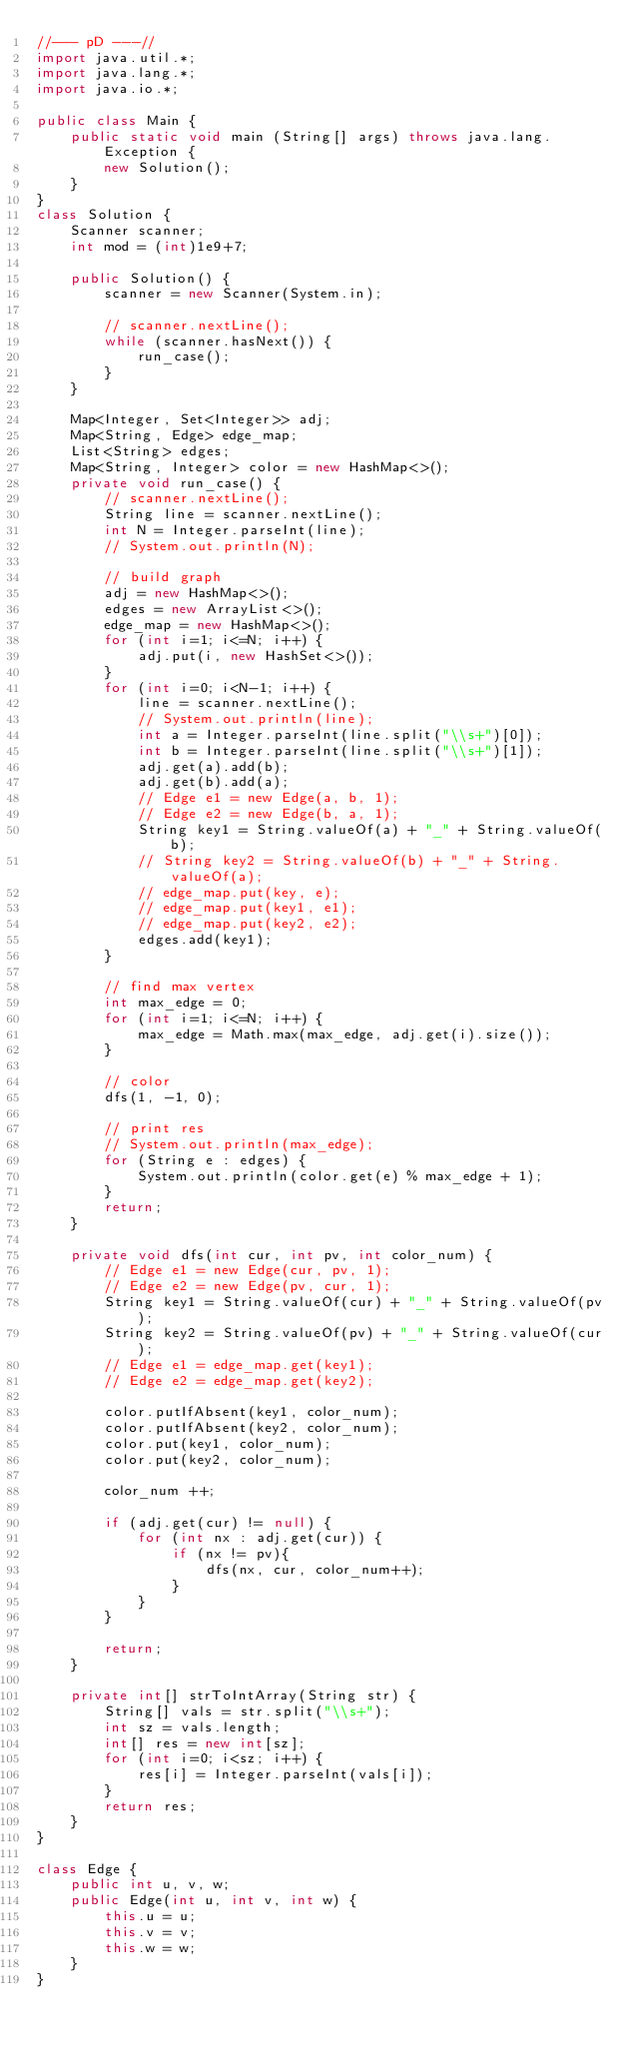<code> <loc_0><loc_0><loc_500><loc_500><_Java_>//--- pD ---//
import java.util.*;
import java.lang.*;
import java.io.*;

public class Main {
	public static void main (String[] args) throws java.lang.Exception {
		new Solution();
	}
}
class Solution {
	Scanner scanner;
	int mod = (int)1e9+7;

	public Solution() {
		scanner = new Scanner(System.in);

		// scanner.nextLine();
		while (scanner.hasNext()) {
			run_case();
		}
	}

	Map<Integer, Set<Integer>> adj;
	Map<String, Edge> edge_map;
	List<String> edges;
	Map<String, Integer> color = new HashMap<>();
	private void run_case() {
		// scanner.nextLine();
		String line = scanner.nextLine();
		int N = Integer.parseInt(line);
		// System.out.println(N);

		// build graph
		adj = new HashMap<>();
		edges = new ArrayList<>();
		edge_map = new HashMap<>();
		for (int i=1; i<=N; i++) {
			adj.put(i, new HashSet<>());
		}
		for (int i=0; i<N-1; i++) {
			line = scanner.nextLine();
			// System.out.println(line);
			int a = Integer.parseInt(line.split("\\s+")[0]);
			int b = Integer.parseInt(line.split("\\s+")[1]);
			adj.get(a).add(b);
			adj.get(b).add(a);
			// Edge e1 = new Edge(a, b, 1);
			// Edge e2 = new Edge(b, a, 1);
			String key1 = String.valueOf(a) + "_" + String.valueOf(b);
			// String key2 = String.valueOf(b) + "_" + String.valueOf(a);
			// edge_map.put(key, e);
			// edge_map.put(key1, e1);
			// edge_map.put(key2, e2);
			edges.add(key1);
		}

		// find max vertex
		int max_edge = 0;
		for (int i=1; i<=N; i++) {
			max_edge = Math.max(max_edge, adj.get(i).size());
		}

		// color
		dfs(1, -1, 0);

		// print res
		// System.out.println(max_edge);
		for (String e : edges) {
			System.out.println(color.get(e) % max_edge + 1);
		}
		return;
	}

	private void dfs(int cur, int pv, int color_num) {
		// Edge e1 = new Edge(cur, pv, 1);
		// Edge e2 = new Edge(pv, cur, 1);
		String key1 = String.valueOf(cur) + "_" + String.valueOf(pv);
		String key2 = String.valueOf(pv) + "_" + String.valueOf(cur);
		// Edge e1 = edge_map.get(key1);
		// Edge e2 = edge_map.get(key2);

	    color.putIfAbsent(key1, color_num);
		color.putIfAbsent(key2, color_num);
		color.put(key1, color_num);
		color.put(key2, color_num);

		color_num ++;

		if (adj.get(cur) != null) {
		    for (int nx : adj.get(cur)) {
				if (nx != pv){
		        	dfs(nx, cur, color_num++);
				}
		    }
		}

		return;
	}

	private int[] strToIntArray(String str) {
	    String[] vals = str.split("\\s+");
	    int sz = vals.length;
	    int[] res = new int[sz];
	    for (int i=0; i<sz; i++) {
	        res[i] = Integer.parseInt(vals[i]);
	    }
	    return res;
	}
}

class Edge {
    public int u, v, w;
    public Edge(int u, int v, int w) {
        this.u = u;
        this.v = v;
        this.w = w;
    }
}
</code> 